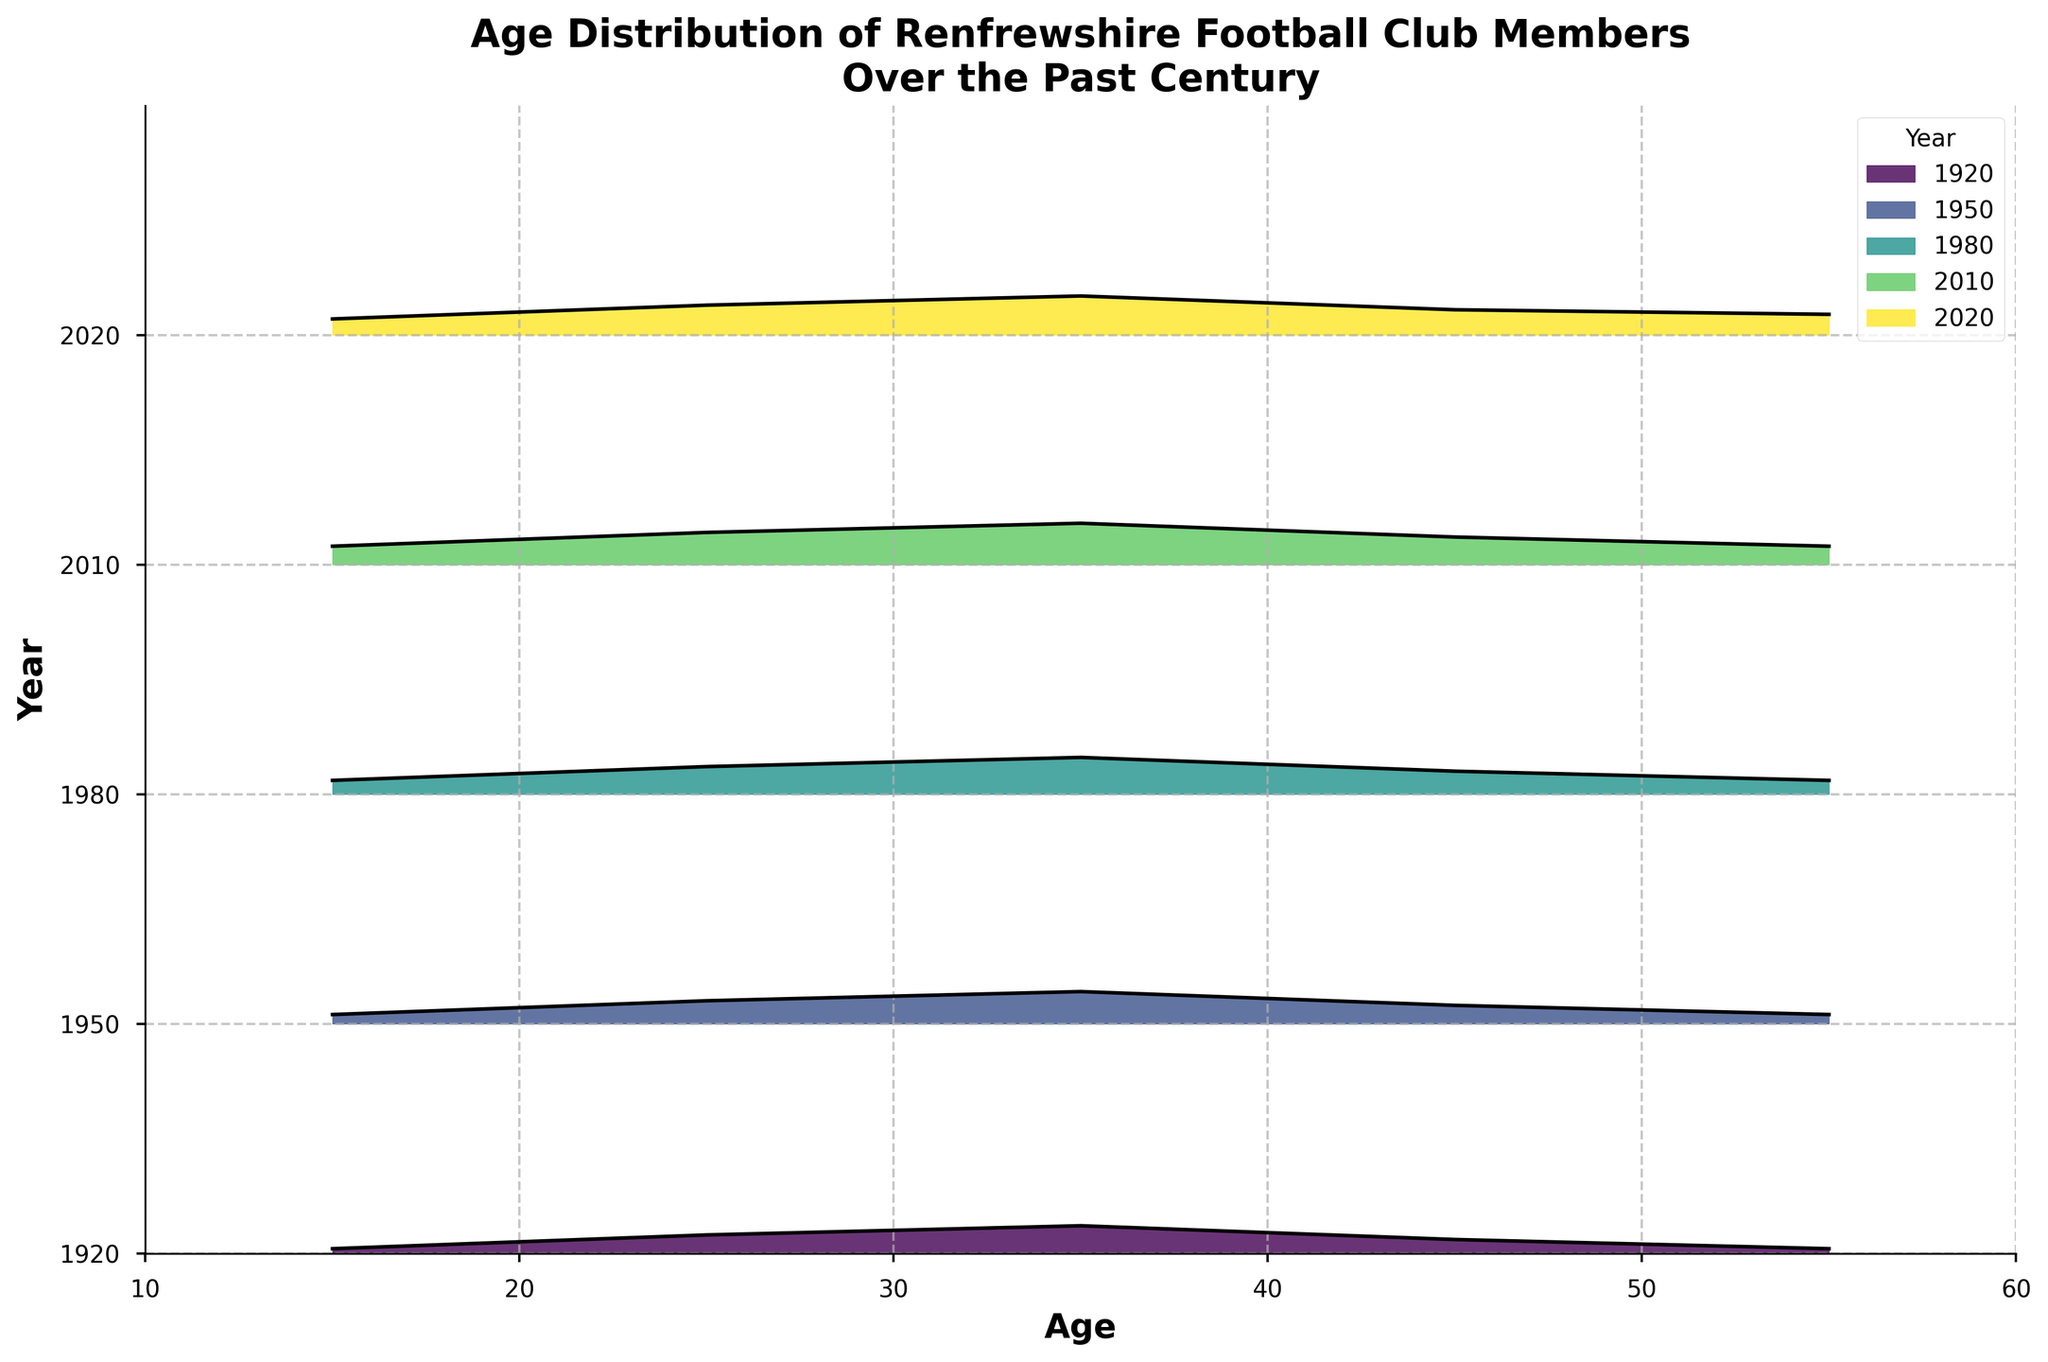What is the title of the figure? The title of the figure is located at the top and provides a summary of what the plot is about. It reads: 'Age Distribution of Renfrewshire Football Club Members Over the Past Century'.
Answer: Age Distribution of Renfrewshire Football Club Members Over the Past Century What does the x-axis represent in the plot? The x-axis represents the ages of the football club members, ranging from 10 to 60 years.
Answer: Age How many different years are depicted in the plot? The years are each denoted with a different color in the ridgeline plot. By counting the distinct colored lines, we can see there are five different years: 1920, 1950, 1980, 2010, and 2020.
Answer: 5 Which year shows the highest density of members aged 35? By looking at the height of the filled area at age 35 in each year, we can observe that the year 2010 shows the highest density.
Answer: 2010 Which age group has consistently shown an increase in density over the years? By tracing the lines and filled areas for each age group across the different years, it becomes clear that the age group 35 has shown a consistent increase in density over the years.
Answer: 35 How did the density of members aged 25 change from 1920 to 2020? The density values for members aged 25 are: 0.08 (1920), 0.10 (1950), 0.12 (1980), 0.14 (2010), and 0.13 (2020). This shows a general increase from 1920 to 2010 and a slight decrease in 2020.
Answer: Increased and then slightly decreased What is the trend for the density of members aged 15 from 1950 to 2020? Reading the plot at age 15 for the years from 1950 to 2020, the densities are: 0.04 (1950), 0.06 (1980), 0.08 (2010), and 0.07 (2020). This indicates an increasing trend up to 2010, followed by a slight decrease in density in 2020.
Answer: Increased and then slightly decreased In terms of overall density, which age group appears to be most popular in the year 2010? To determine the most popular age group in 2010, we look for the highest peak in the curve for that year. The age group 35 has the highest density at 0.18, making it the most popular.
Answer: 35 Compare the densities of members aged 45 in 1920 and 2020. Which year had a higher density? Comparing the density values for members aged 45 in both years shows: 0.06 (1920) and 0.11 (2020). Thus, 2020 had a higher density.
Answer: 2020 What significant trends can you identify for members aged 55 over the century? Observing the density for age 55 in all the years: 0.02 (1920), 0.04 (1950), 0.06 (1980), 0.08 (2010), and 0.09 (2020), we can see a consistent increase in density over the entire century.
Answer: Consistent increase 